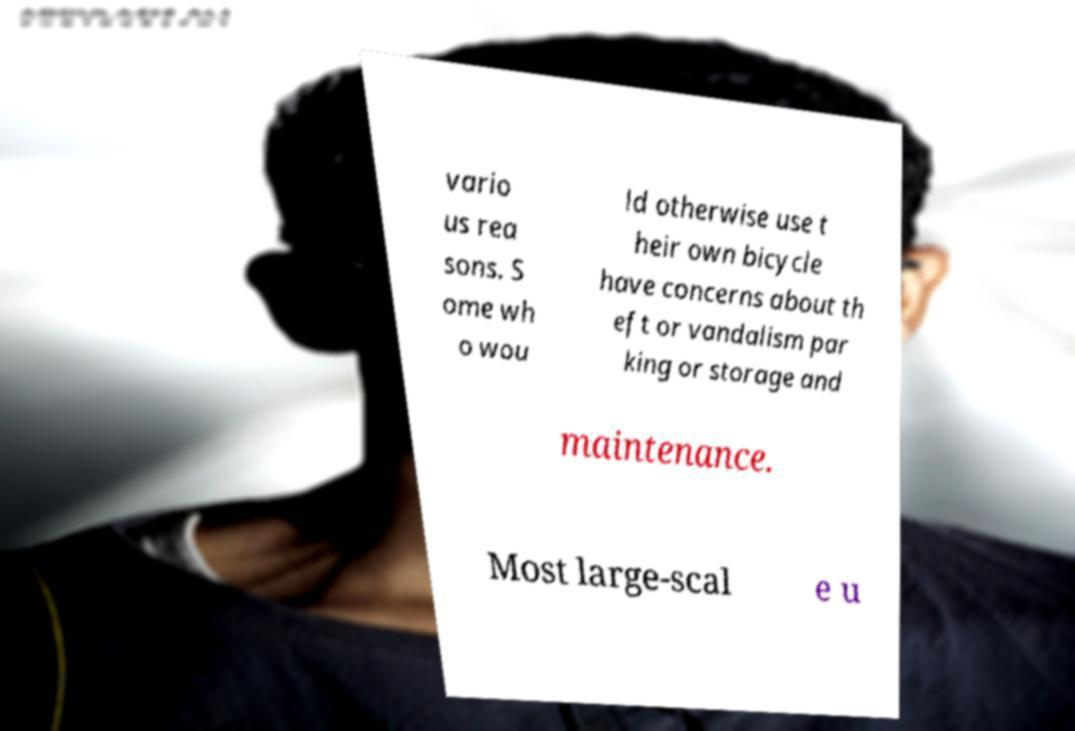Can you accurately transcribe the text from the provided image for me? vario us rea sons. S ome wh o wou ld otherwise use t heir own bicycle have concerns about th eft or vandalism par king or storage and maintenance. Most large-scal e u 